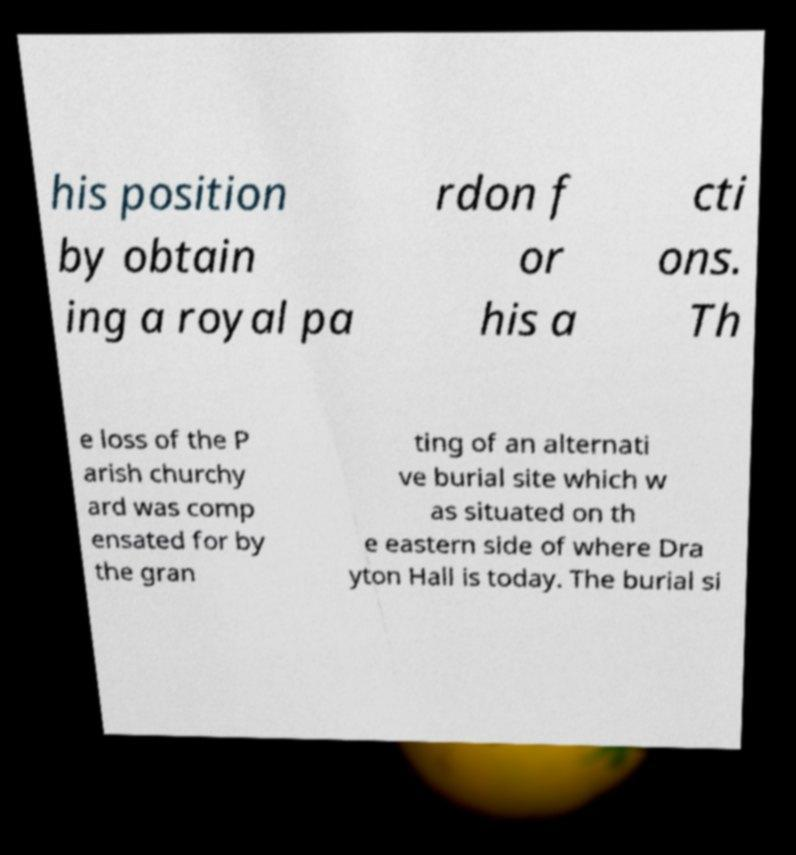There's text embedded in this image that I need extracted. Can you transcribe it verbatim? his position by obtain ing a royal pa rdon f or his a cti ons. Th e loss of the P arish churchy ard was comp ensated for by the gran ting of an alternati ve burial site which w as situated on th e eastern side of where Dra yton Hall is today. The burial si 